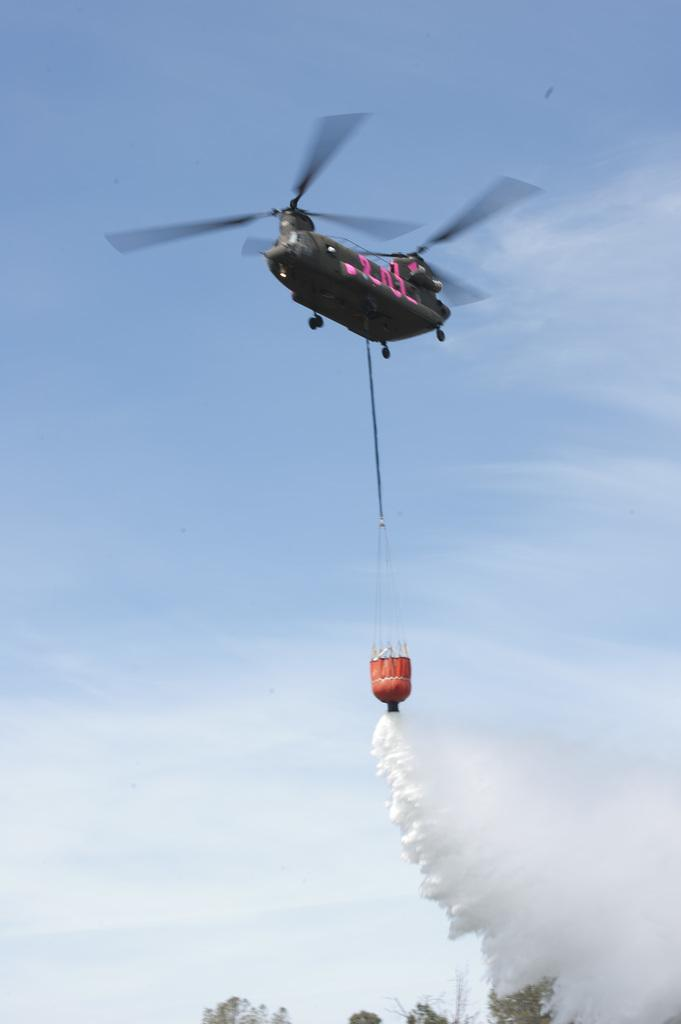What is the main object in the image? There is an object in the image, but its specific nature is not mentioned in the facts. What is attached to or associated with the object? There is a rope in the image, which may be connected to the object. What can be seen in the image that might indicate activity or movement? There is smoke in the image, which could suggest that the object is producing smoke or is involved in some kind of activity. What type of vehicle is present in the image? There is a helicopter in the image. What type of natural environment is visible in the image? There are trees in the image, which suggests a forest or wooded area. What is visible in the background of the image? The sky is visible in the background of the image. What letters are being passed around during recess in the image? There is no mention of recess or letters in the image, so this question cannot be answered definitively. 